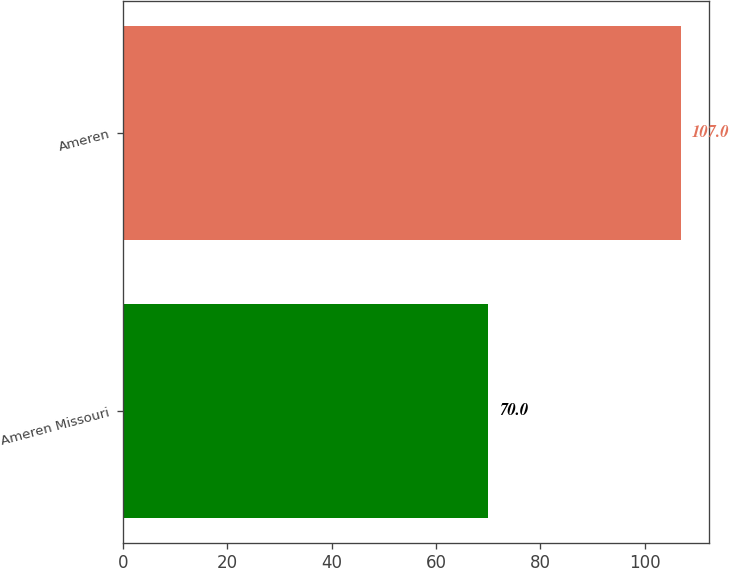Convert chart to OTSL. <chart><loc_0><loc_0><loc_500><loc_500><bar_chart><fcel>Ameren Missouri<fcel>Ameren<nl><fcel>70<fcel>107<nl></chart> 